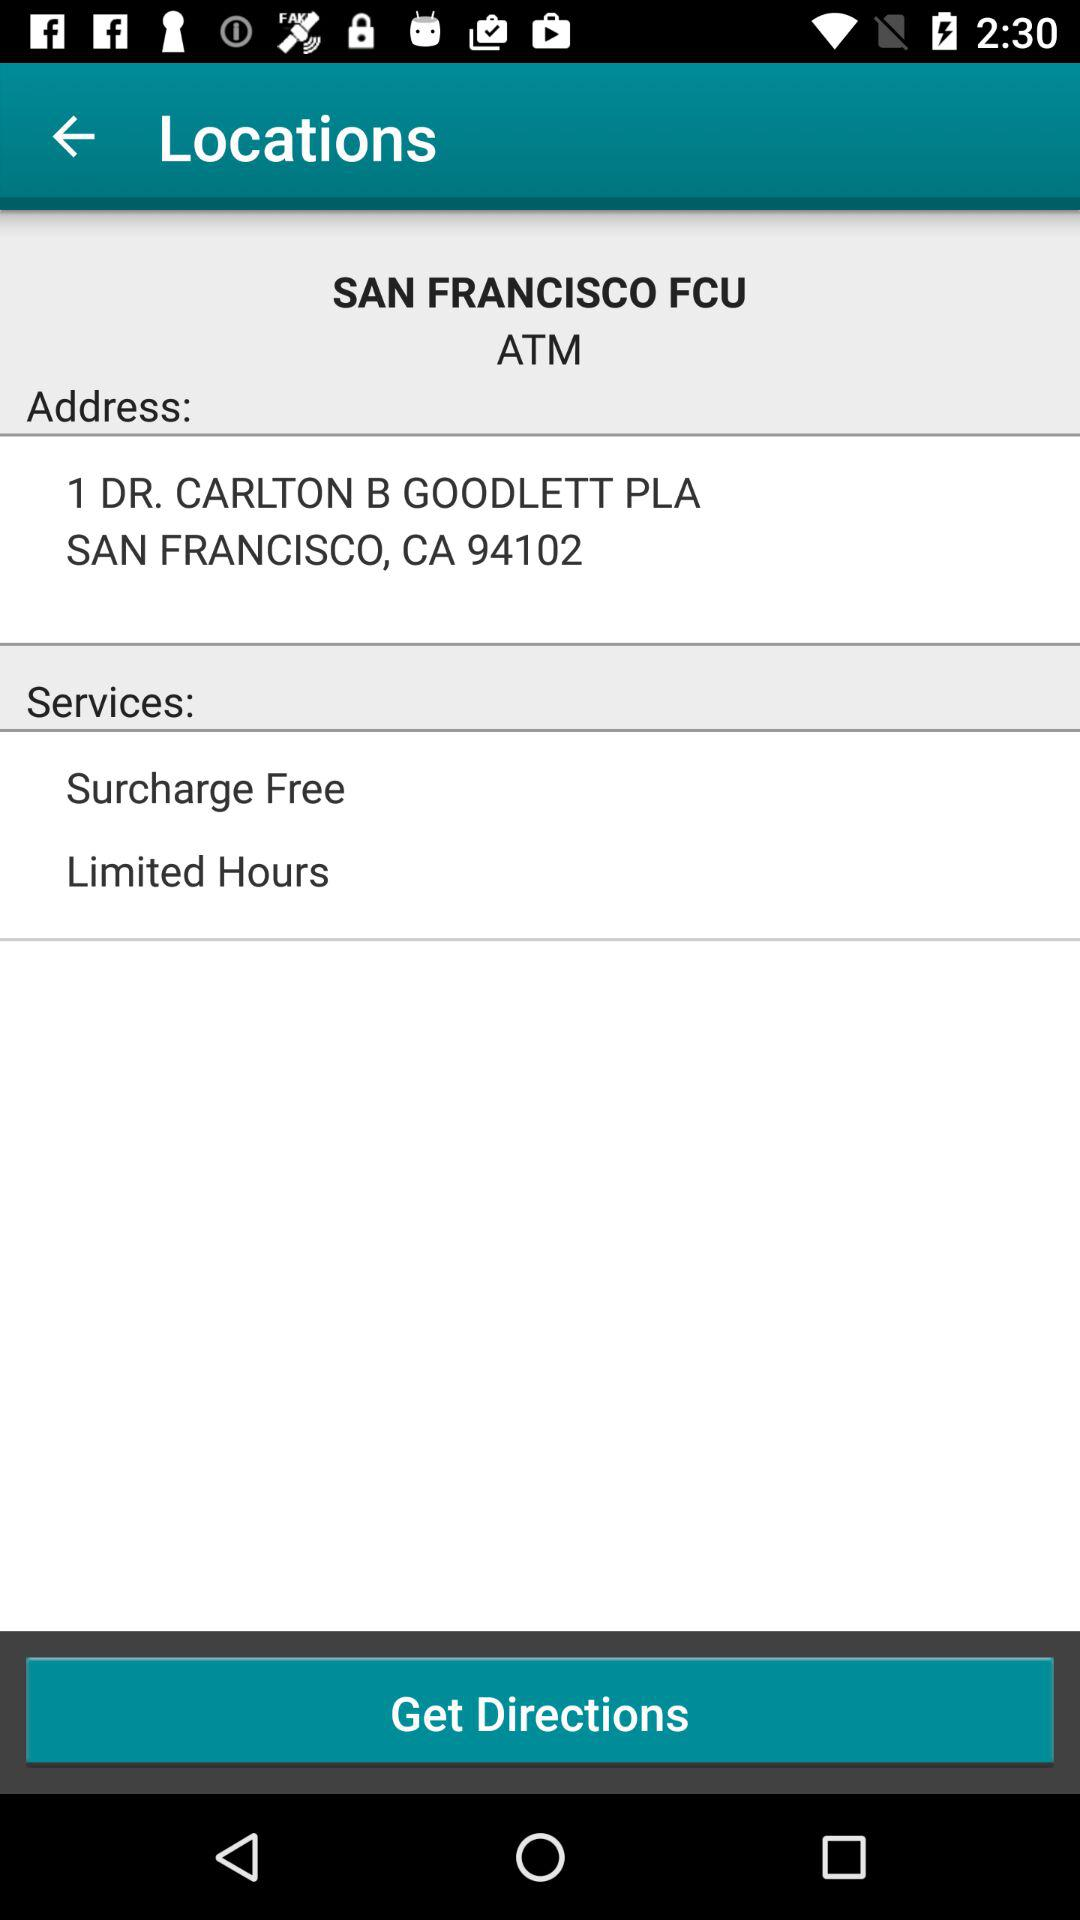What is the address of the ATM? The address of the ATM is 1 Dr. Carlton B. Goodlett Place, San Francisco, CA 94102. 